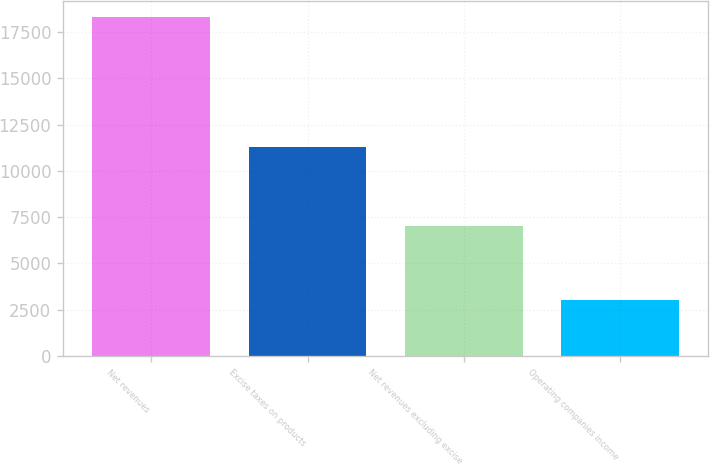Convert chart. <chart><loc_0><loc_0><loc_500><loc_500><bar_chart><fcel>Net revenues<fcel>Excise taxes on products<fcel>Net revenues excluding excise<fcel>Operating companies income<nl><fcel>18286<fcel>11286<fcel>7000<fcel>3016<nl></chart> 